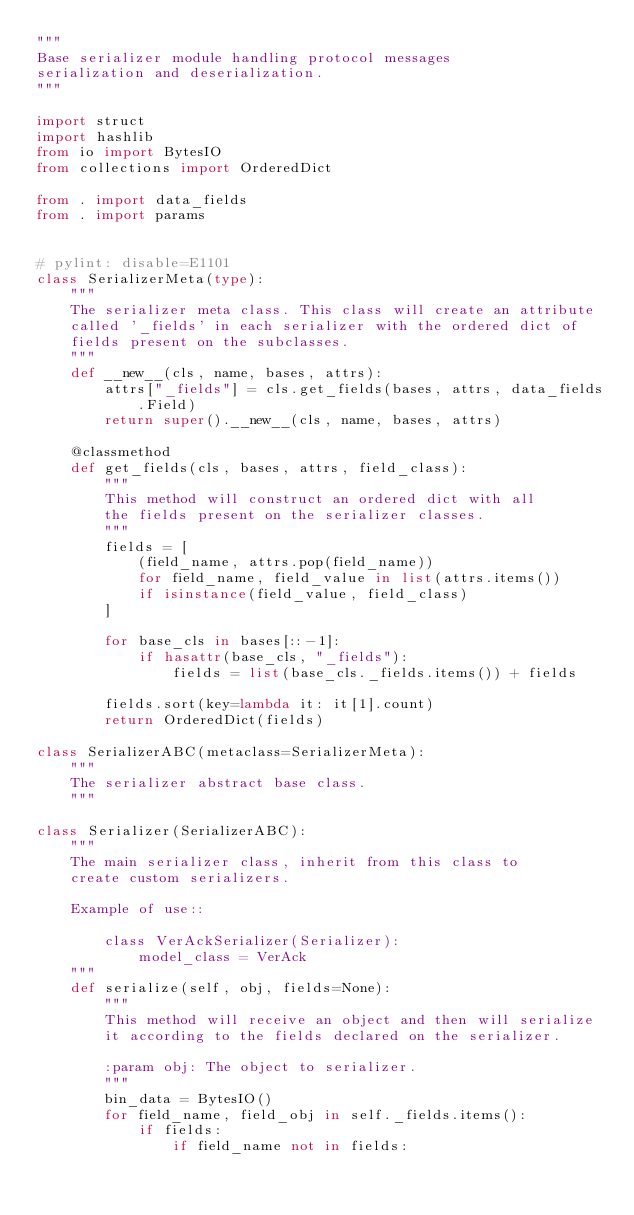Convert code to text. <code><loc_0><loc_0><loc_500><loc_500><_Python_>"""
Base serializer module handling protocol messages
serialization and deserialization.
"""

import struct
import hashlib
from io import BytesIO
from collections import OrderedDict

from . import data_fields
from . import params


# pylint: disable=E1101
class SerializerMeta(type):
    """
    The serializer meta class. This class will create an attribute
    called '_fields' in each serializer with the ordered dict of
    fields present on the subclasses.
    """
    def __new__(cls, name, bases, attrs):
        attrs["_fields"] = cls.get_fields(bases, attrs, data_fields.Field)
        return super().__new__(cls, name, bases, attrs)

    @classmethod
    def get_fields(cls, bases, attrs, field_class):
        """
        This method will construct an ordered dict with all
        the fields present on the serializer classes.
        """
        fields = [
            (field_name, attrs.pop(field_name))
            for field_name, field_value in list(attrs.items())
            if isinstance(field_value, field_class)
        ]

        for base_cls in bases[::-1]:
            if hasattr(base_cls, "_fields"):
                fields = list(base_cls._fields.items()) + fields

        fields.sort(key=lambda it: it[1].count)
        return OrderedDict(fields)

class SerializerABC(metaclass=SerializerMeta):
    """
    The serializer abstract base class.
    """

class Serializer(SerializerABC):
    """
    The main serializer class, inherit from this class to
    create custom serializers.

    Example of use::

        class VerAckSerializer(Serializer):
            model_class = VerAck
    """
    def serialize(self, obj, fields=None):
        """
        This method will receive an object and then will serialize
        it according to the fields declared on the serializer.

        :param obj: The object to serializer.
        """
        bin_data = BytesIO()
        for field_name, field_obj in self._fields.items():
            if fields:
                if field_name not in fields:</code> 